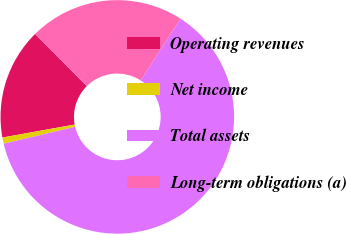Convert chart to OTSL. <chart><loc_0><loc_0><loc_500><loc_500><pie_chart><fcel>Operating revenues<fcel>Net income<fcel>Total assets<fcel>Long-term obligations (a)<nl><fcel>15.4%<fcel>0.86%<fcel>62.21%<fcel>21.53%<nl></chart> 